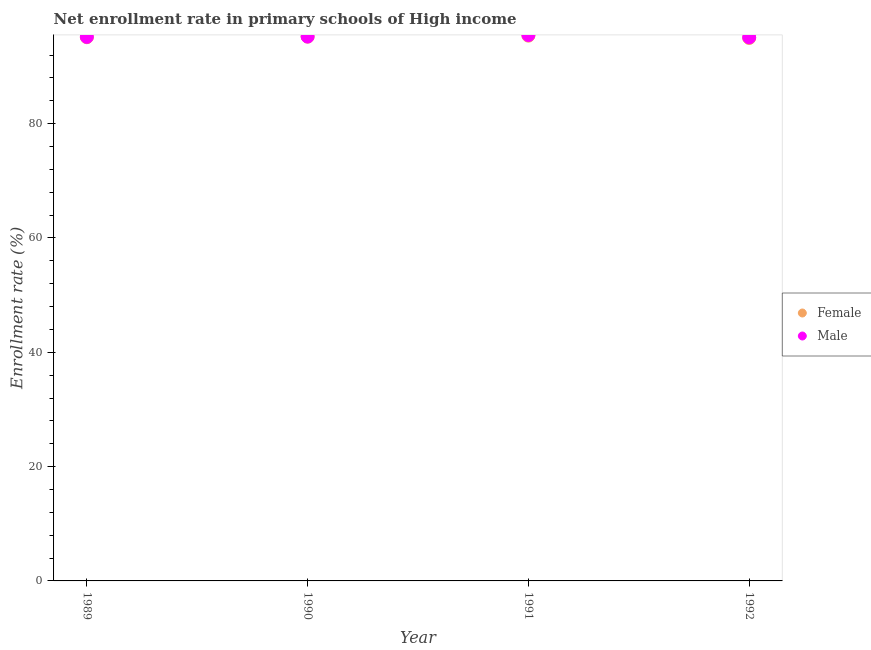How many different coloured dotlines are there?
Offer a very short reply. 2. Is the number of dotlines equal to the number of legend labels?
Your answer should be compact. Yes. What is the enrollment rate of female students in 1992?
Provide a succinct answer. 94.99. Across all years, what is the maximum enrollment rate of female students?
Provide a short and direct response. 95.39. Across all years, what is the minimum enrollment rate of male students?
Give a very brief answer. 95.1. In which year was the enrollment rate of female students maximum?
Offer a terse response. 1991. In which year was the enrollment rate of female students minimum?
Keep it short and to the point. 1992. What is the total enrollment rate of male students in the graph?
Give a very brief answer. 381.02. What is the difference between the enrollment rate of female students in 1989 and that in 1990?
Keep it short and to the point. -0.1. What is the difference between the enrollment rate of female students in 1990 and the enrollment rate of male students in 1992?
Ensure brevity in your answer.  0.12. What is the average enrollment rate of male students per year?
Offer a very short reply. 95.25. In the year 1992, what is the difference between the enrollment rate of male students and enrollment rate of female students?
Your answer should be very brief. 0.11. In how many years, is the enrollment rate of male students greater than 44 %?
Provide a succinct answer. 4. What is the ratio of the enrollment rate of male students in 1989 to that in 1991?
Your response must be concise. 1. Is the difference between the enrollment rate of female students in 1989 and 1992 greater than the difference between the enrollment rate of male students in 1989 and 1992?
Give a very brief answer. Yes. What is the difference between the highest and the second highest enrollment rate of male students?
Keep it short and to the point. 0.27. What is the difference between the highest and the lowest enrollment rate of female students?
Your answer should be very brief. 0.41. In how many years, is the enrollment rate of male students greater than the average enrollment rate of male students taken over all years?
Provide a short and direct response. 1. Is the sum of the enrollment rate of female students in 1991 and 1992 greater than the maximum enrollment rate of male students across all years?
Provide a short and direct response. Yes. Does the enrollment rate of male students monotonically increase over the years?
Ensure brevity in your answer.  No. Is the enrollment rate of female students strictly less than the enrollment rate of male students over the years?
Give a very brief answer. Yes. How many dotlines are there?
Offer a very short reply. 2. What is the difference between two consecutive major ticks on the Y-axis?
Give a very brief answer. 20. What is the title of the graph?
Provide a short and direct response. Net enrollment rate in primary schools of High income. Does "Export" appear as one of the legend labels in the graph?
Offer a very short reply. No. What is the label or title of the Y-axis?
Your answer should be very brief. Enrollment rate (%). What is the Enrollment rate (%) of Female in 1989?
Offer a terse response. 95.12. What is the Enrollment rate (%) in Male in 1989?
Offer a terse response. 95.18. What is the Enrollment rate (%) in Female in 1990?
Your response must be concise. 95.22. What is the Enrollment rate (%) in Male in 1990?
Provide a short and direct response. 95.24. What is the Enrollment rate (%) of Female in 1991?
Provide a succinct answer. 95.39. What is the Enrollment rate (%) in Male in 1991?
Give a very brief answer. 95.51. What is the Enrollment rate (%) of Female in 1992?
Keep it short and to the point. 94.99. What is the Enrollment rate (%) in Male in 1992?
Your response must be concise. 95.1. Across all years, what is the maximum Enrollment rate (%) of Female?
Give a very brief answer. 95.39. Across all years, what is the maximum Enrollment rate (%) of Male?
Ensure brevity in your answer.  95.51. Across all years, what is the minimum Enrollment rate (%) in Female?
Your answer should be compact. 94.99. Across all years, what is the minimum Enrollment rate (%) in Male?
Ensure brevity in your answer.  95.1. What is the total Enrollment rate (%) of Female in the graph?
Provide a succinct answer. 380.72. What is the total Enrollment rate (%) in Male in the graph?
Provide a short and direct response. 381.02. What is the difference between the Enrollment rate (%) in Female in 1989 and that in 1990?
Make the answer very short. -0.1. What is the difference between the Enrollment rate (%) of Male in 1989 and that in 1990?
Provide a short and direct response. -0.06. What is the difference between the Enrollment rate (%) of Female in 1989 and that in 1991?
Keep it short and to the point. -0.27. What is the difference between the Enrollment rate (%) of Male in 1989 and that in 1991?
Offer a very short reply. -0.33. What is the difference between the Enrollment rate (%) of Female in 1989 and that in 1992?
Offer a terse response. 0.14. What is the difference between the Enrollment rate (%) of Male in 1989 and that in 1992?
Ensure brevity in your answer.  0.08. What is the difference between the Enrollment rate (%) of Female in 1990 and that in 1991?
Offer a very short reply. -0.17. What is the difference between the Enrollment rate (%) in Male in 1990 and that in 1991?
Make the answer very short. -0.27. What is the difference between the Enrollment rate (%) of Female in 1990 and that in 1992?
Make the answer very short. 0.23. What is the difference between the Enrollment rate (%) of Male in 1990 and that in 1992?
Offer a terse response. 0.14. What is the difference between the Enrollment rate (%) in Female in 1991 and that in 1992?
Your response must be concise. 0.41. What is the difference between the Enrollment rate (%) in Male in 1991 and that in 1992?
Make the answer very short. 0.41. What is the difference between the Enrollment rate (%) in Female in 1989 and the Enrollment rate (%) in Male in 1990?
Provide a succinct answer. -0.11. What is the difference between the Enrollment rate (%) in Female in 1989 and the Enrollment rate (%) in Male in 1991?
Your answer should be compact. -0.38. What is the difference between the Enrollment rate (%) of Female in 1989 and the Enrollment rate (%) of Male in 1992?
Your answer should be compact. 0.03. What is the difference between the Enrollment rate (%) of Female in 1990 and the Enrollment rate (%) of Male in 1991?
Make the answer very short. -0.29. What is the difference between the Enrollment rate (%) in Female in 1990 and the Enrollment rate (%) in Male in 1992?
Give a very brief answer. 0.12. What is the difference between the Enrollment rate (%) in Female in 1991 and the Enrollment rate (%) in Male in 1992?
Ensure brevity in your answer.  0.3. What is the average Enrollment rate (%) in Female per year?
Offer a very short reply. 95.18. What is the average Enrollment rate (%) in Male per year?
Offer a very short reply. 95.25. In the year 1989, what is the difference between the Enrollment rate (%) in Female and Enrollment rate (%) in Male?
Offer a very short reply. -0.06. In the year 1990, what is the difference between the Enrollment rate (%) in Female and Enrollment rate (%) in Male?
Keep it short and to the point. -0.02. In the year 1991, what is the difference between the Enrollment rate (%) of Female and Enrollment rate (%) of Male?
Give a very brief answer. -0.11. In the year 1992, what is the difference between the Enrollment rate (%) of Female and Enrollment rate (%) of Male?
Ensure brevity in your answer.  -0.11. What is the ratio of the Enrollment rate (%) of Female in 1989 to that in 1990?
Give a very brief answer. 1. What is the ratio of the Enrollment rate (%) of Female in 1989 to that in 1991?
Your answer should be compact. 1. What is the ratio of the Enrollment rate (%) of Male in 1989 to that in 1992?
Offer a very short reply. 1. What is the ratio of the Enrollment rate (%) of Female in 1990 to that in 1991?
Your answer should be compact. 1. What is the ratio of the Enrollment rate (%) of Male in 1990 to that in 1992?
Provide a succinct answer. 1. What is the ratio of the Enrollment rate (%) in Female in 1991 to that in 1992?
Keep it short and to the point. 1. What is the difference between the highest and the second highest Enrollment rate (%) of Female?
Your answer should be compact. 0.17. What is the difference between the highest and the second highest Enrollment rate (%) of Male?
Give a very brief answer. 0.27. What is the difference between the highest and the lowest Enrollment rate (%) of Female?
Offer a very short reply. 0.41. What is the difference between the highest and the lowest Enrollment rate (%) in Male?
Keep it short and to the point. 0.41. 